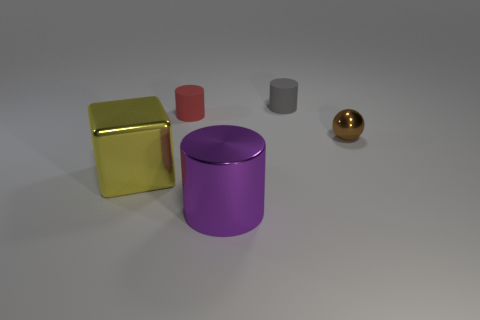Add 5 tiny brown metallic things. How many objects exist? 10 Subtract all cylinders. How many objects are left? 2 Add 3 large yellow shiny cubes. How many large yellow shiny cubes exist? 4 Subtract 1 purple cylinders. How many objects are left? 4 Subtract all cylinders. Subtract all small gray matte cylinders. How many objects are left? 1 Add 4 big yellow metallic blocks. How many big yellow metallic blocks are left? 5 